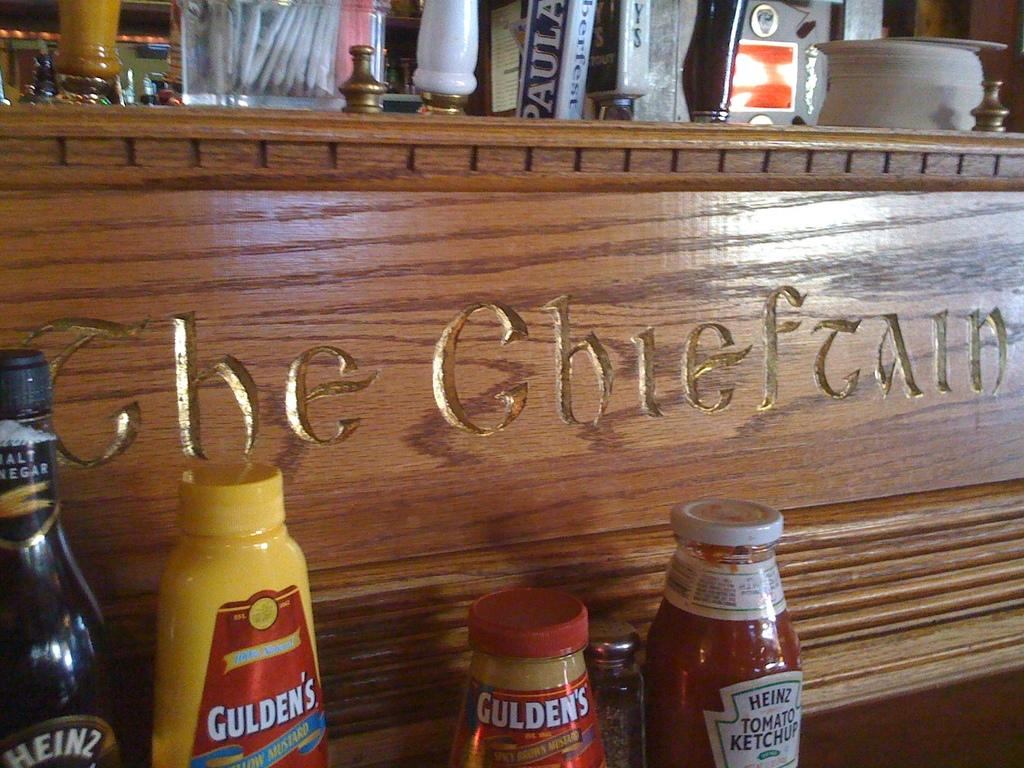<image>
Summarize the visual content of the image. Various condiments are laid out in front of a wooden sign that says The Chieftain. 